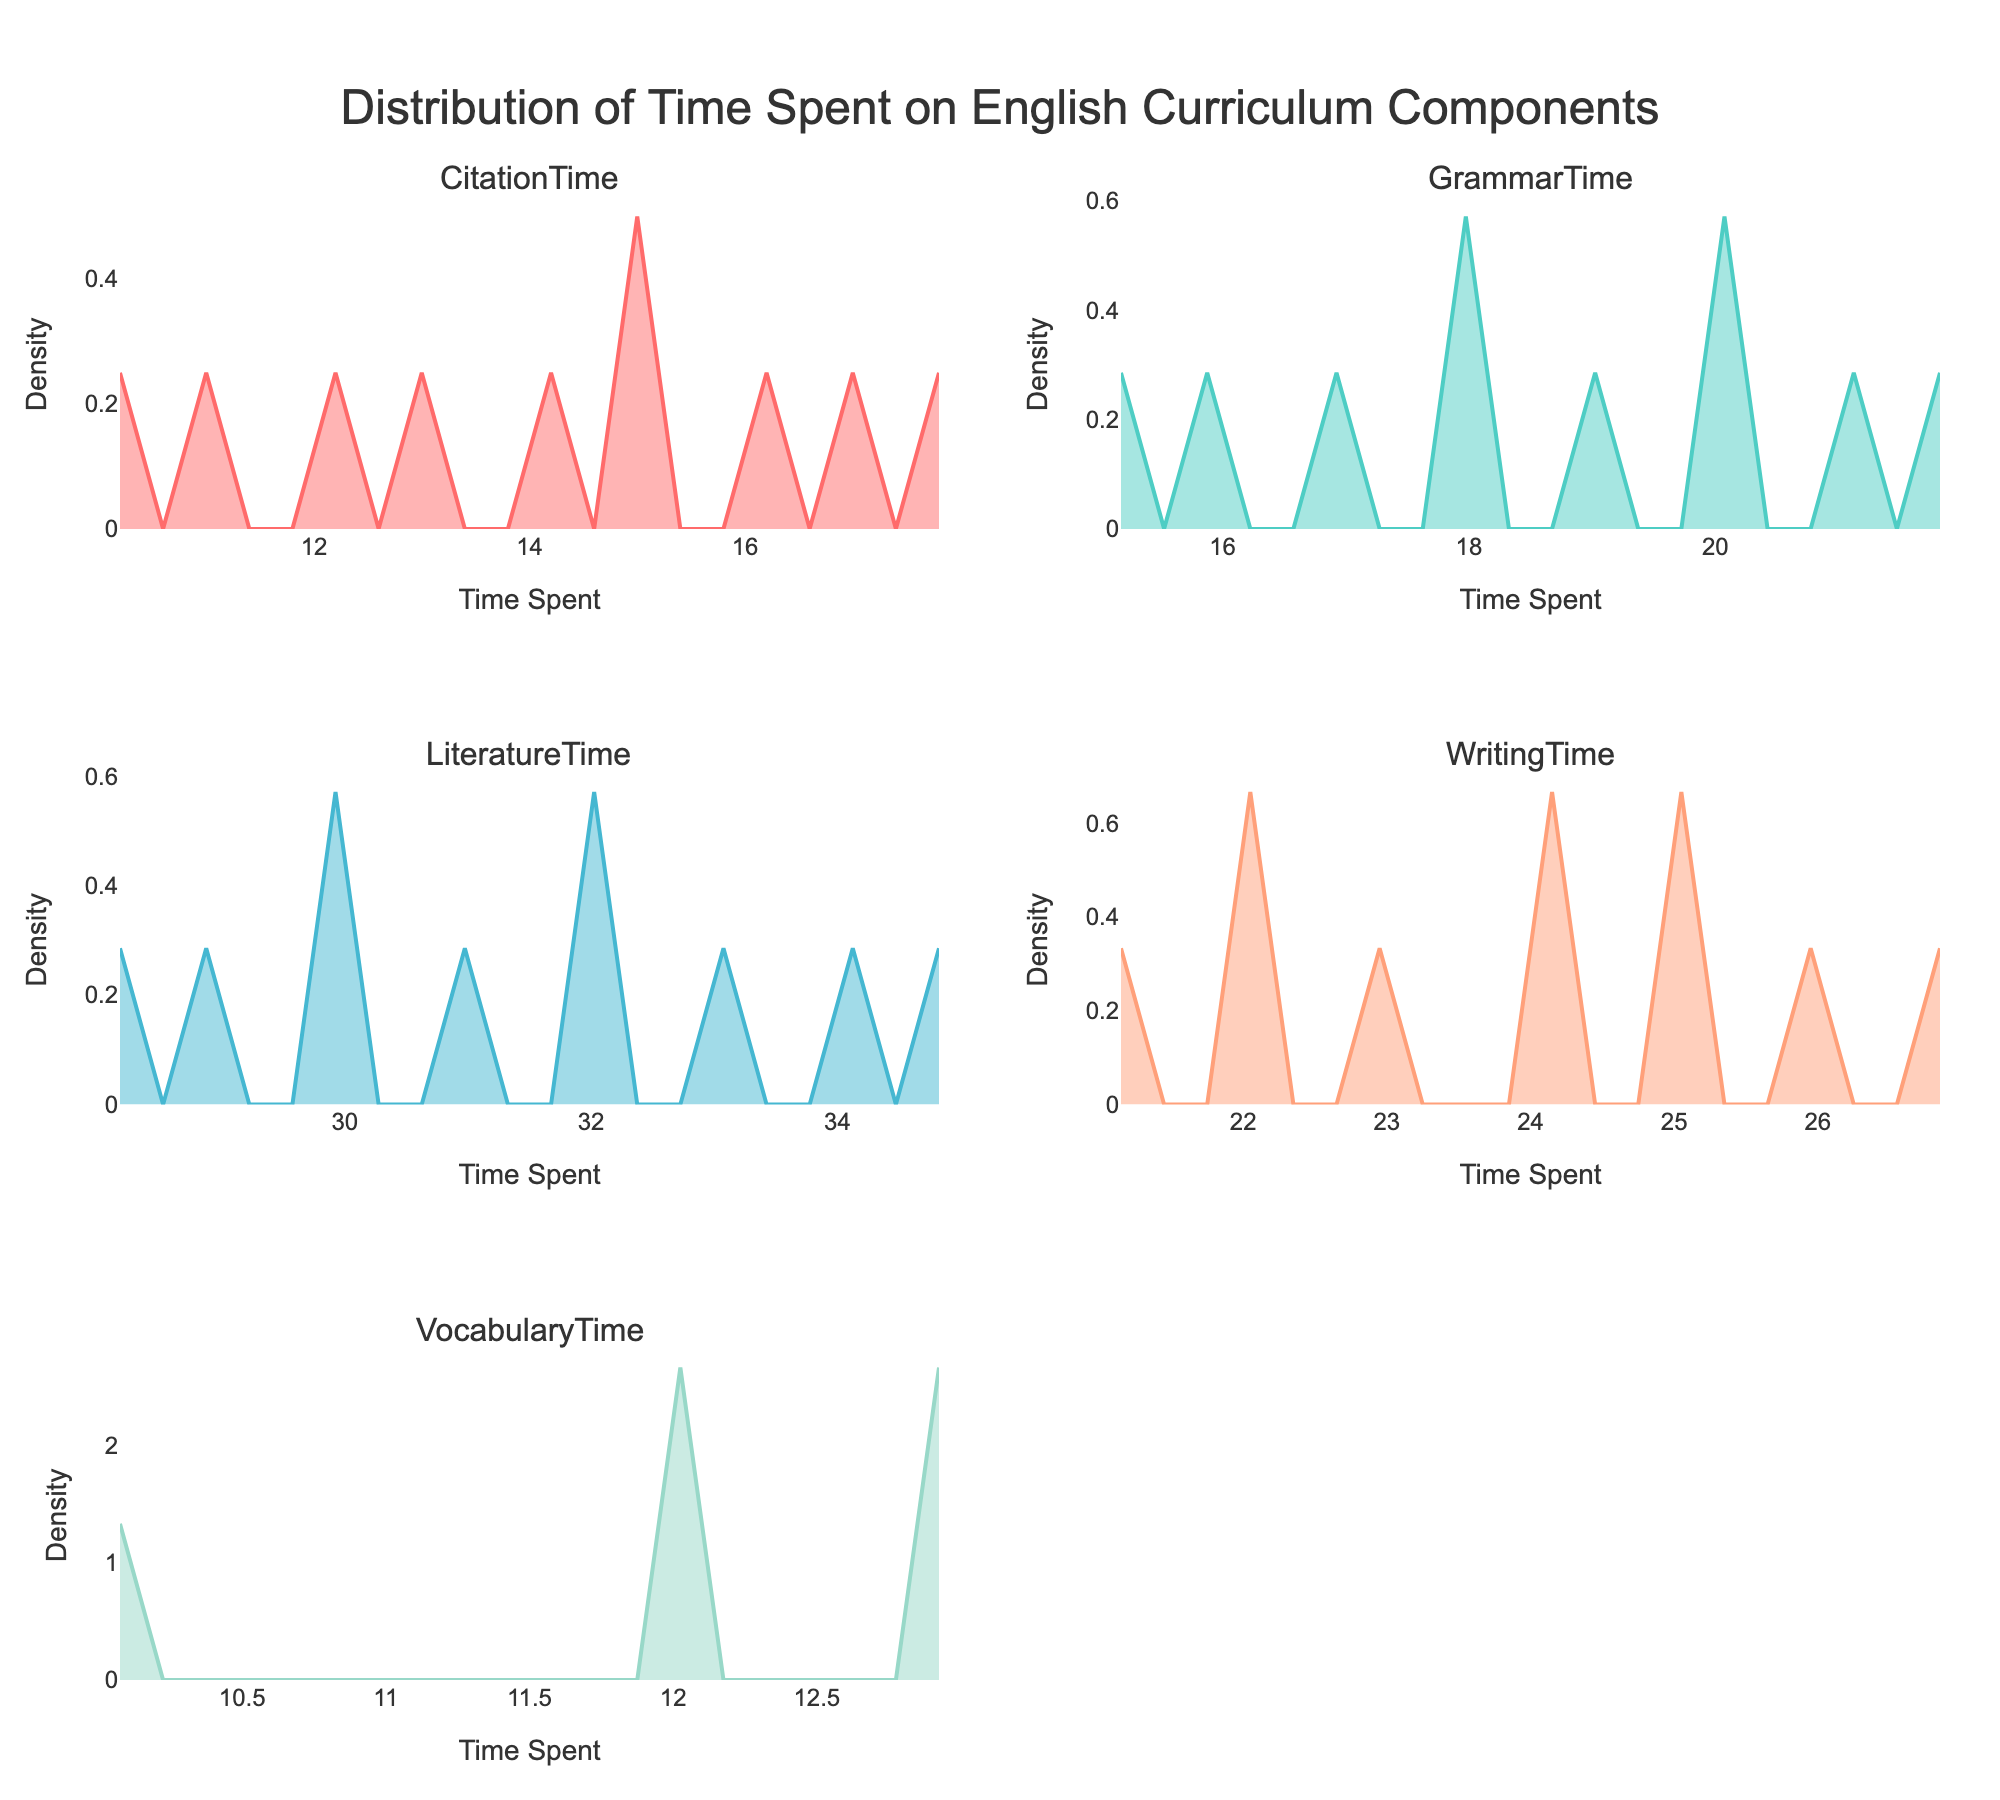What's the title of the plot? The title is found at the top-center of the plot.
Answer: "Distribution of Time Spent on English Curriculum Components" How many subplots are there, and what are their titles? Count the number of subplots from their positions. The titles of the subplots are listed at the top of each one.
Answer: 6 subplots with titles: "CitationTime", "GrammarTime", "LiteratureTime", "WritingTime", "VocabularyTime", "Density" What color is the 'GrammarTime' density plot line? Identify the 'GrammarTime' subplot, then observe the color of the line within that subplot.
Answer: Light green Which subplot shows the distribution of 'CitationTime'? Look at the titles labeled above each subplot to find 'CitationTime'.
Answer: The subplot in row 1, column 1 Which component has a wider distribution: 'WritingTime' or 'VocabularyTime'? Compare the horizontal (x-axis) range of the density plots for 'WritingTime' and 'VocabularyTime'.
Answer: 'WritingTime' What is the peak density value for 'LiteratureTime'? Identify the highest point (peak) of the density plot for 'LiteratureTime' and read the y-axis value.
Answer: Approximately 0.03 Looking at the 'CitationTime' subplot, what can you infer about the distribution of how much time is spent teaching citation methods? Observe the shape of the density plot for 'CitationTime'; note the spread and height of the curve.
Answer: The time spent on teaching citation methods is moderately concentrated, with some variation Which curriculum component has the most concentrated time distribution? Identify the subplot with the highest peak density, indicating a highly concentrated distribution.
Answer: 'GrammarTime' On average, do schools spend more time on 'LiteratureTime' or 'GrammarTime'? Compare the x-axis range and the peak positions for 'LiteratureTime' and 'GrammarTime'.
Answer: 'LiteratureTime' How do the distributions of 'CitationTime' and 'LiteratureTime' compare in terms of shape and spread? Examine both 'CitationTime' and 'LiteratureTime' subplots, noting the shape and spread of their density curves.
Answer: 'CitationTime' is more evenly spread, while 'LiteratureTime' has a wider spread with a lower peak density Do any of the distributions show a bi-modal pattern (having two peaks)? Look through each subplot to see if any curves have two distinct peaks.
Answer: No distributions show a bi-modal pattern 